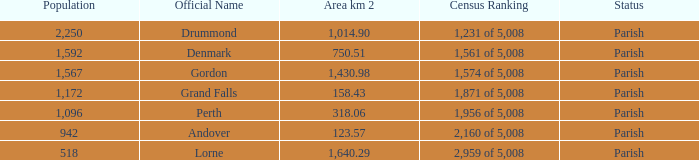Which parish has an area of 750.51? Denmark. 